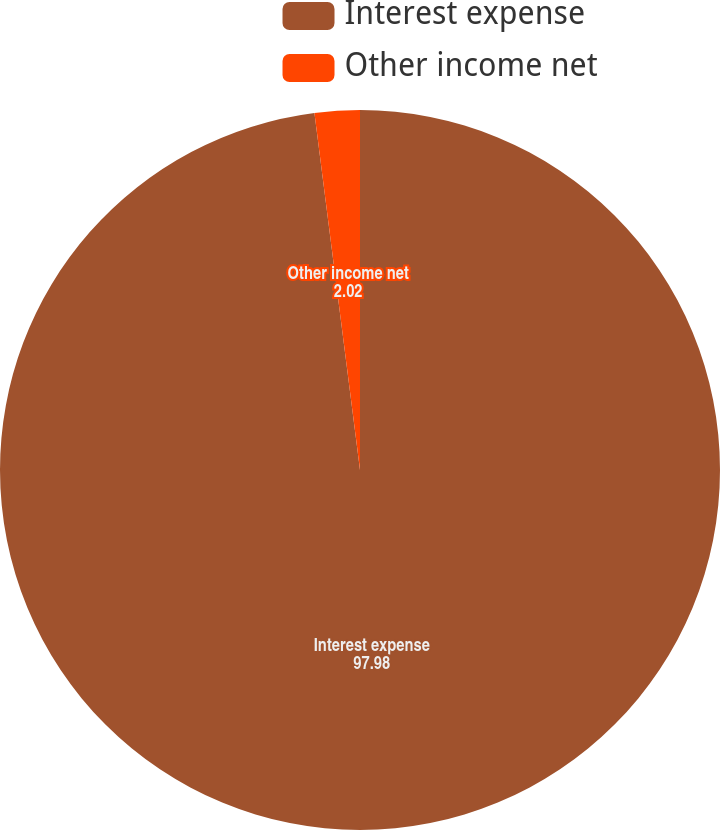<chart> <loc_0><loc_0><loc_500><loc_500><pie_chart><fcel>Interest expense<fcel>Other income net<nl><fcel>97.98%<fcel>2.02%<nl></chart> 